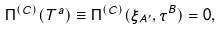<formula> <loc_0><loc_0><loc_500><loc_500>\Pi ^ { ( C ) } ( T ^ { a } ) \equiv \Pi ^ { ( C ) } ( \xi _ { A ^ { \prime } } , \tau ^ { B } ) = 0 ,</formula> 